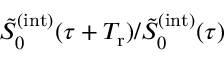Convert formula to latex. <formula><loc_0><loc_0><loc_500><loc_500>\tilde { S } _ { 0 } ^ { ( i n t ) } ( \tau + T _ { r } ) / \tilde { S } _ { 0 } ^ { ( i n t ) } ( \tau )</formula> 